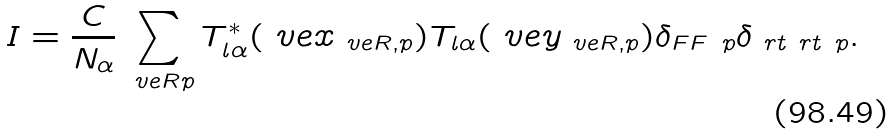Convert formula to latex. <formula><loc_0><loc_0><loc_500><loc_500>I = \frac { C } { N _ { \alpha } } \sum _ { \ v e { R } p } T _ { l \alpha } ^ { \ast } ( \ v e { x } _ { \ v e { R } , p } ) T _ { l \alpha } ( \ v e { y } _ { \ v e { R } , p } ) \delta _ { F F ^ { \ } p } \delta _ { \ r t \ r t ^ { \ } p } .</formula> 